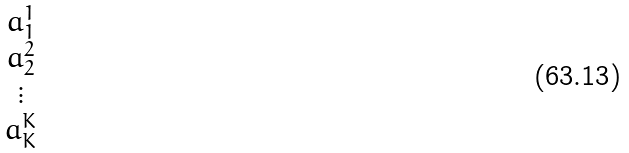Convert formula to latex. <formula><loc_0><loc_0><loc_500><loc_500>\begin{matrix} a _ { 1 } ^ { 1 } \\ a _ { 2 } ^ { 2 } \\ \vdots \\ a _ { K } ^ { K } \end{matrix}</formula> 